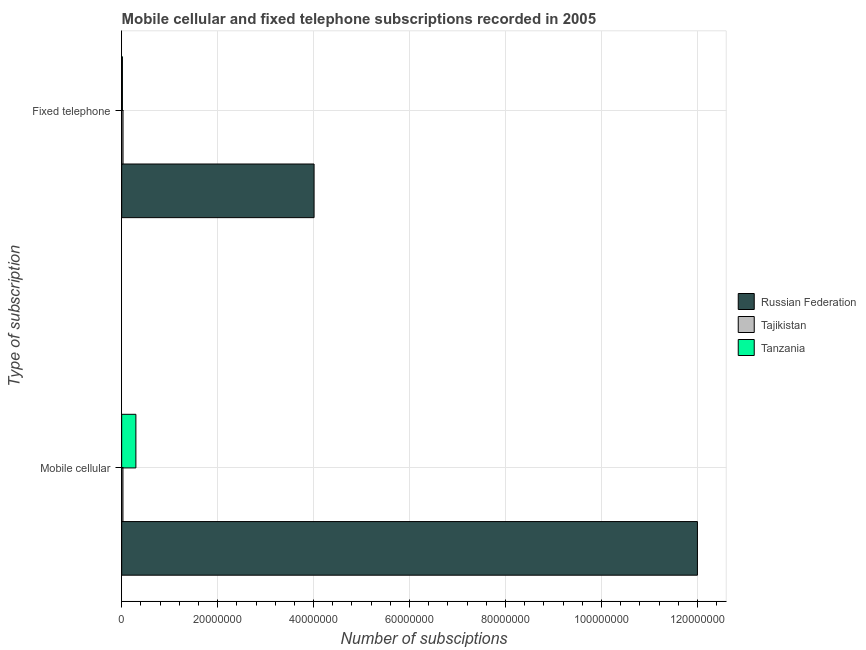How many different coloured bars are there?
Offer a very short reply. 3. Are the number of bars on each tick of the Y-axis equal?
Offer a very short reply. Yes. How many bars are there on the 1st tick from the top?
Provide a succinct answer. 3. What is the label of the 1st group of bars from the top?
Your answer should be compact. Fixed telephone. What is the number of mobile cellular subscriptions in Russian Federation?
Your answer should be very brief. 1.20e+08. Across all countries, what is the maximum number of mobile cellular subscriptions?
Offer a very short reply. 1.20e+08. Across all countries, what is the minimum number of fixed telephone subscriptions?
Your answer should be compact. 1.54e+05. In which country was the number of mobile cellular subscriptions maximum?
Your response must be concise. Russian Federation. In which country was the number of mobile cellular subscriptions minimum?
Keep it short and to the point. Tajikistan. What is the total number of mobile cellular subscriptions in the graph?
Offer a terse response. 1.23e+08. What is the difference between the number of fixed telephone subscriptions in Russian Federation and that in Tanzania?
Provide a succinct answer. 3.99e+07. What is the difference between the number of fixed telephone subscriptions in Tanzania and the number of mobile cellular subscriptions in Tajikistan?
Provide a succinct answer. -1.11e+05. What is the average number of mobile cellular subscriptions per country?
Your response must be concise. 4.11e+07. What is the difference between the number of mobile cellular subscriptions and number of fixed telephone subscriptions in Tanzania?
Your answer should be compact. 2.81e+06. What is the ratio of the number of mobile cellular subscriptions in Tanzania to that in Russian Federation?
Keep it short and to the point. 0.02. Is the number of fixed telephone subscriptions in Tajikistan less than that in Tanzania?
Your answer should be compact. No. In how many countries, is the number of mobile cellular subscriptions greater than the average number of mobile cellular subscriptions taken over all countries?
Offer a very short reply. 1. What does the 3rd bar from the top in Mobile cellular represents?
Make the answer very short. Russian Federation. What does the 3rd bar from the bottom in Mobile cellular represents?
Your answer should be compact. Tanzania. How many bars are there?
Your answer should be very brief. 6. Are all the bars in the graph horizontal?
Give a very brief answer. Yes. Are the values on the major ticks of X-axis written in scientific E-notation?
Give a very brief answer. No. Does the graph contain grids?
Your response must be concise. Yes. Where does the legend appear in the graph?
Offer a terse response. Center right. How many legend labels are there?
Provide a succinct answer. 3. How are the legend labels stacked?
Make the answer very short. Vertical. What is the title of the graph?
Provide a short and direct response. Mobile cellular and fixed telephone subscriptions recorded in 2005. Does "Azerbaijan" appear as one of the legend labels in the graph?
Your answer should be compact. No. What is the label or title of the X-axis?
Make the answer very short. Number of subsciptions. What is the label or title of the Y-axis?
Your answer should be very brief. Type of subscription. What is the Number of subsciptions of Russian Federation in Mobile cellular?
Your response must be concise. 1.20e+08. What is the Number of subsciptions of Tajikistan in Mobile cellular?
Your response must be concise. 2.65e+05. What is the Number of subsciptions of Tanzania in Mobile cellular?
Ensure brevity in your answer.  2.96e+06. What is the Number of subsciptions in Russian Federation in Fixed telephone?
Offer a very short reply. 4.01e+07. What is the Number of subsciptions in Tajikistan in Fixed telephone?
Keep it short and to the point. 2.80e+05. What is the Number of subsciptions in Tanzania in Fixed telephone?
Your response must be concise. 1.54e+05. Across all Type of subscription, what is the maximum Number of subsciptions in Russian Federation?
Offer a terse response. 1.20e+08. Across all Type of subscription, what is the maximum Number of subsciptions of Tajikistan?
Offer a very short reply. 2.80e+05. Across all Type of subscription, what is the maximum Number of subsciptions of Tanzania?
Your answer should be compact. 2.96e+06. Across all Type of subscription, what is the minimum Number of subsciptions of Russian Federation?
Ensure brevity in your answer.  4.01e+07. Across all Type of subscription, what is the minimum Number of subsciptions in Tajikistan?
Offer a terse response. 2.65e+05. Across all Type of subscription, what is the minimum Number of subsciptions in Tanzania?
Make the answer very short. 1.54e+05. What is the total Number of subsciptions of Russian Federation in the graph?
Provide a short and direct response. 1.60e+08. What is the total Number of subsciptions of Tajikistan in the graph?
Keep it short and to the point. 5.45e+05. What is the total Number of subsciptions of Tanzania in the graph?
Your response must be concise. 3.12e+06. What is the difference between the Number of subsciptions of Russian Federation in Mobile cellular and that in Fixed telephone?
Keep it short and to the point. 7.99e+07. What is the difference between the Number of subsciptions of Tajikistan in Mobile cellular and that in Fixed telephone?
Give a very brief answer. -1.52e+04. What is the difference between the Number of subsciptions in Tanzania in Mobile cellular and that in Fixed telephone?
Offer a very short reply. 2.81e+06. What is the difference between the Number of subsciptions of Russian Federation in Mobile cellular and the Number of subsciptions of Tajikistan in Fixed telephone?
Provide a short and direct response. 1.20e+08. What is the difference between the Number of subsciptions in Russian Federation in Mobile cellular and the Number of subsciptions in Tanzania in Fixed telephone?
Your response must be concise. 1.20e+08. What is the difference between the Number of subsciptions in Tajikistan in Mobile cellular and the Number of subsciptions in Tanzania in Fixed telephone?
Make the answer very short. 1.11e+05. What is the average Number of subsciptions in Russian Federation per Type of subscription?
Your answer should be very brief. 8.00e+07. What is the average Number of subsciptions in Tajikistan per Type of subscription?
Offer a terse response. 2.73e+05. What is the average Number of subsciptions in Tanzania per Type of subscription?
Give a very brief answer. 1.56e+06. What is the difference between the Number of subsciptions of Russian Federation and Number of subsciptions of Tajikistan in Mobile cellular?
Your answer should be compact. 1.20e+08. What is the difference between the Number of subsciptions in Russian Federation and Number of subsciptions in Tanzania in Mobile cellular?
Ensure brevity in your answer.  1.17e+08. What is the difference between the Number of subsciptions of Tajikistan and Number of subsciptions of Tanzania in Mobile cellular?
Offer a terse response. -2.70e+06. What is the difference between the Number of subsciptions of Russian Federation and Number of subsciptions of Tajikistan in Fixed telephone?
Keep it short and to the point. 3.98e+07. What is the difference between the Number of subsciptions in Russian Federation and Number of subsciptions in Tanzania in Fixed telephone?
Make the answer very short. 3.99e+07. What is the difference between the Number of subsciptions of Tajikistan and Number of subsciptions of Tanzania in Fixed telephone?
Your response must be concise. 1.26e+05. What is the ratio of the Number of subsciptions in Russian Federation in Mobile cellular to that in Fixed telephone?
Offer a terse response. 2.99. What is the ratio of the Number of subsciptions of Tajikistan in Mobile cellular to that in Fixed telephone?
Offer a terse response. 0.95. What is the ratio of the Number of subsciptions of Tanzania in Mobile cellular to that in Fixed telephone?
Make the answer very short. 19.2. What is the difference between the highest and the second highest Number of subsciptions of Russian Federation?
Make the answer very short. 7.99e+07. What is the difference between the highest and the second highest Number of subsciptions of Tajikistan?
Your answer should be compact. 1.52e+04. What is the difference between the highest and the second highest Number of subsciptions of Tanzania?
Offer a terse response. 2.81e+06. What is the difference between the highest and the lowest Number of subsciptions in Russian Federation?
Provide a succinct answer. 7.99e+07. What is the difference between the highest and the lowest Number of subsciptions of Tajikistan?
Provide a short and direct response. 1.52e+04. What is the difference between the highest and the lowest Number of subsciptions of Tanzania?
Ensure brevity in your answer.  2.81e+06. 